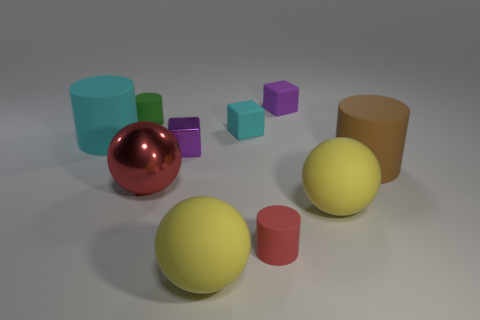Subtract all matte balls. How many balls are left? 1 Subtract 1 cylinders. How many cylinders are left? 3 Subtract all red cylinders. How many cylinders are left? 3 Subtract all blue cylinders. Subtract all gray balls. How many cylinders are left? 4 Subtract all cubes. How many objects are left? 7 Subtract all yellow cubes. Subtract all small rubber blocks. How many objects are left? 8 Add 7 green rubber cylinders. How many green rubber cylinders are left? 8 Add 5 tiny red rubber things. How many tiny red rubber things exist? 6 Subtract 0 gray blocks. How many objects are left? 10 